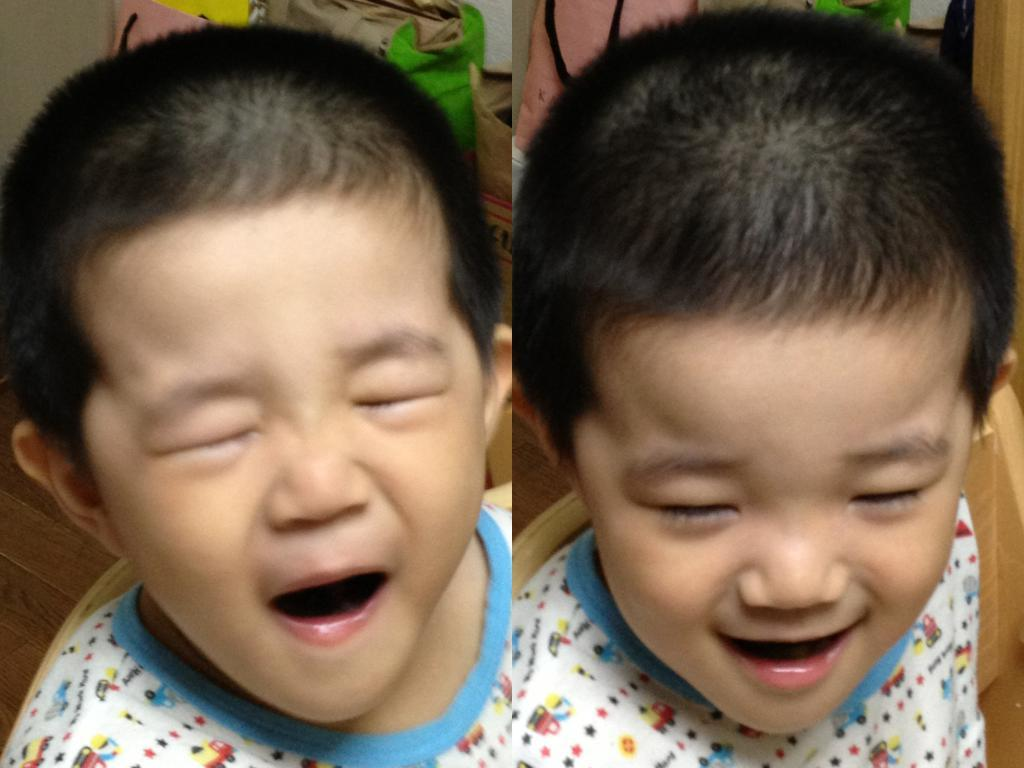What is the composition of the image? The image is a collage of two images. What is common between the two images? In both images, there is a kid sitting on a chair. What type of noise can be heard coming from the office in the image? There is no office present in the image, so it's not possible to determine what, if any, noise might be heard. 